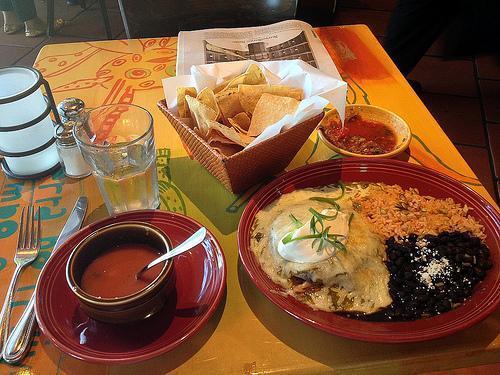How many people is the meal for?
Give a very brief answer. 1. 